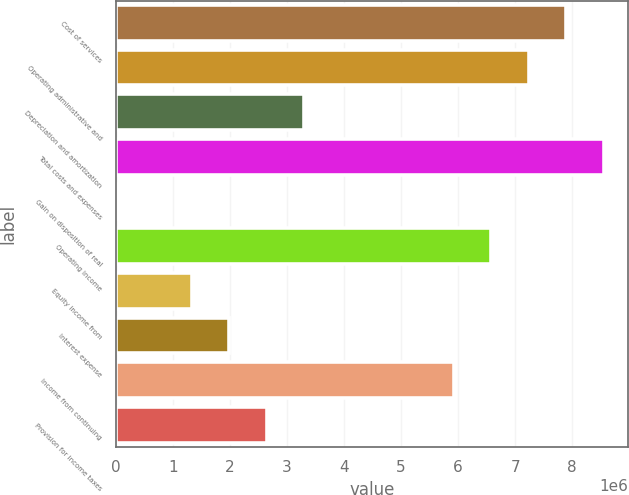Convert chart. <chart><loc_0><loc_0><loc_500><loc_500><bar_chart><fcel>Cost of services<fcel>Operating administrative and<fcel>Depreciation and amortization<fcel>Total costs and expenses<fcel>Gain on disposition of real<fcel>Operating income<fcel>Equity income from<fcel>Interest expense<fcel>Income from continuing<fcel>Provision for income taxes<nl><fcel>7.89595e+06<fcel>7.23908e+06<fcel>3.29788e+06<fcel>8.55282e+06<fcel>13552<fcel>6.58222e+06<fcel>1.32729e+06<fcel>1.98415e+06<fcel>5.92535e+06<fcel>2.64102e+06<nl></chart> 